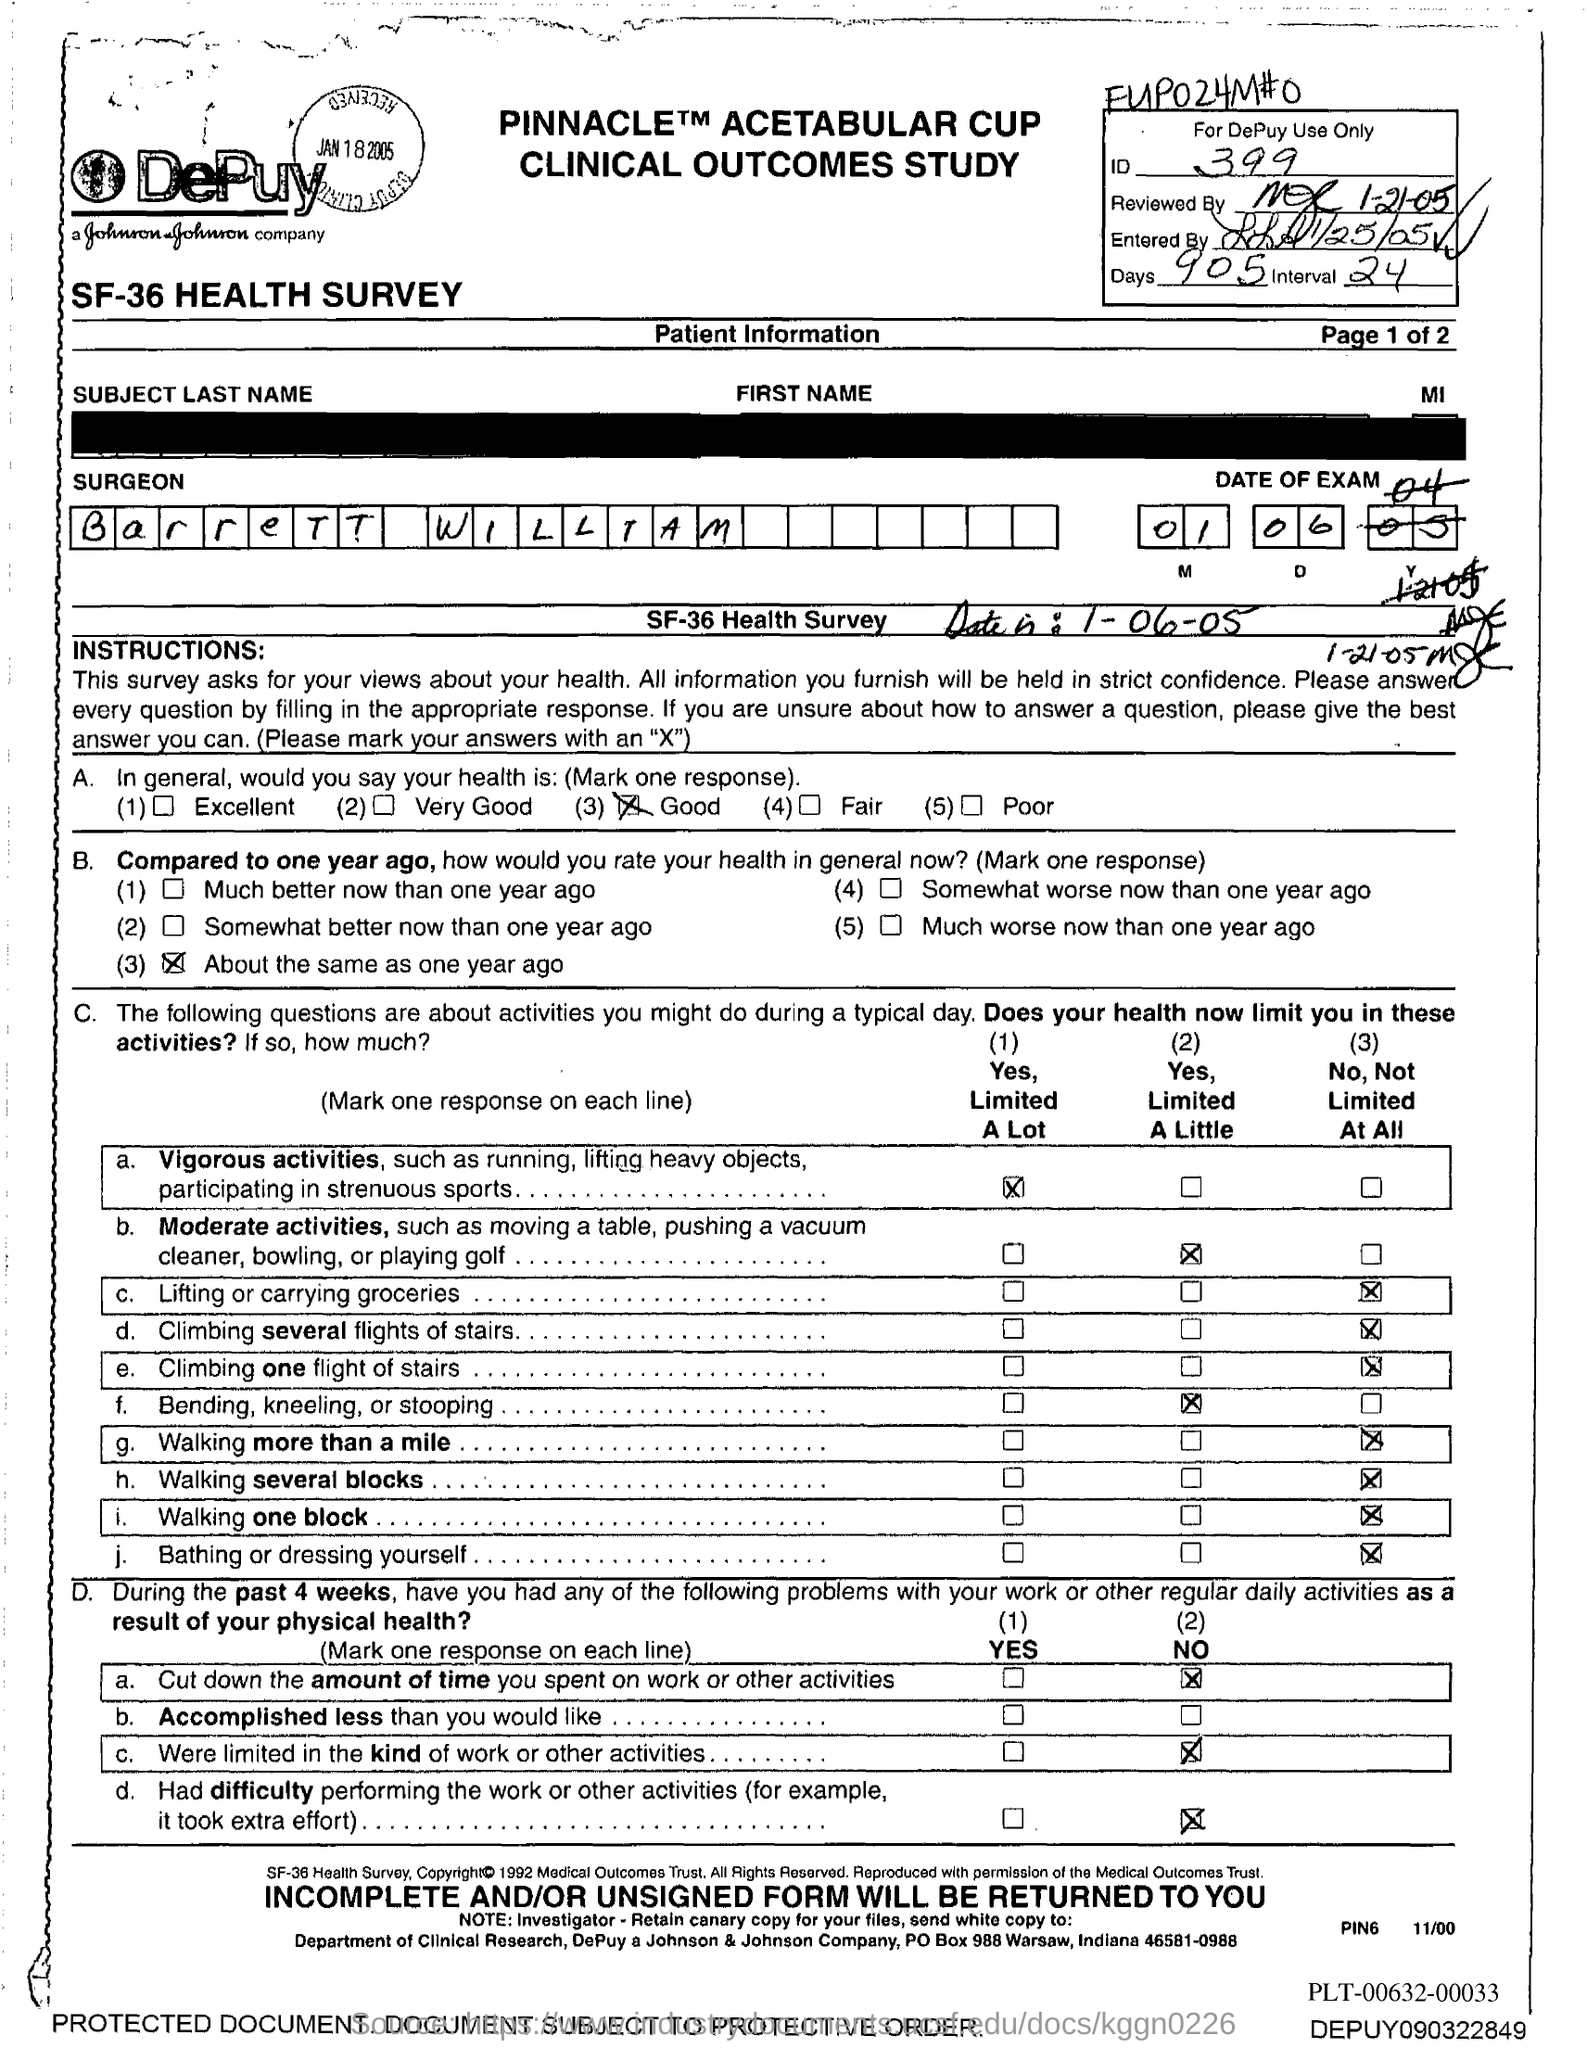What is the id no ?
Offer a very short reply. 399. What is the name of the surgeon ?
Keep it short and to the point. Barrett william. What is the po box no. of johnson & johnson company ?
Keep it short and to the point. 988. In which state is johnson & johnson company located ?
Provide a succinct answer. Indiana. 